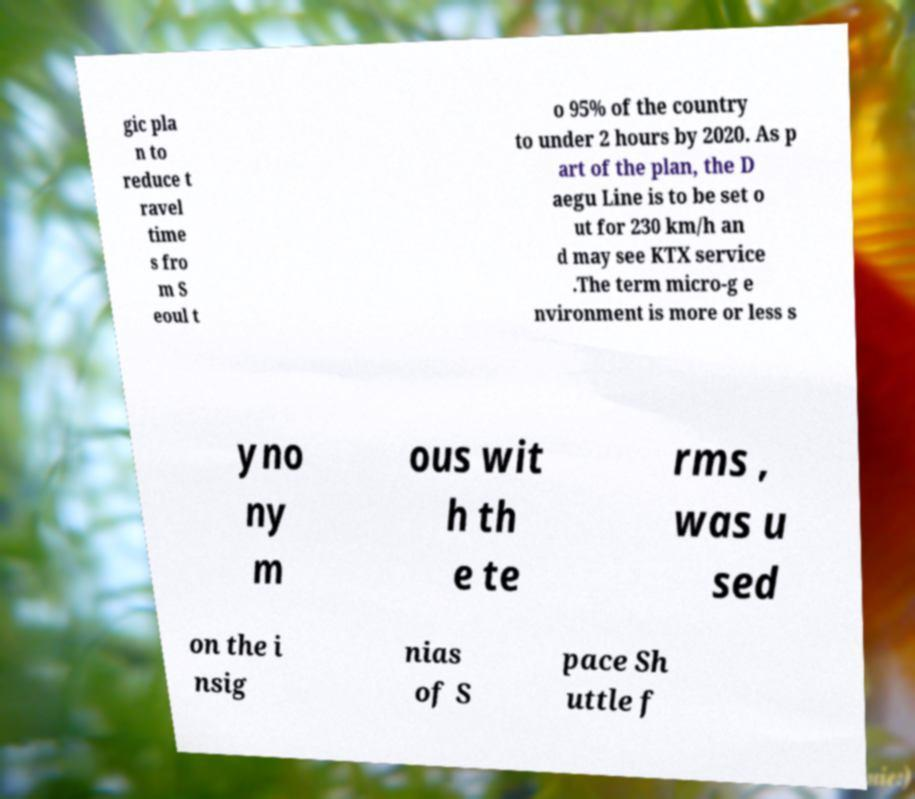Can you read and provide the text displayed in the image?This photo seems to have some interesting text. Can you extract and type it out for me? gic pla n to reduce t ravel time s fro m S eoul t o 95% of the country to under 2 hours by 2020. As p art of the plan, the D aegu Line is to be set o ut for 230 km/h an d may see KTX service .The term micro-g e nvironment is more or less s yno ny m ous wit h th e te rms , was u sed on the i nsig nias of S pace Sh uttle f 